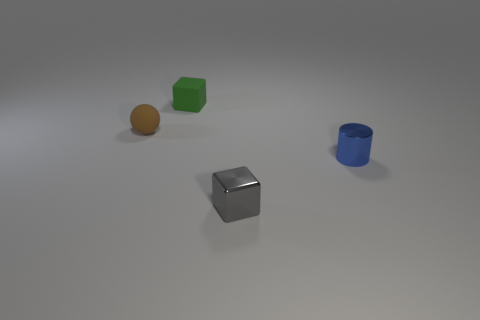What number of metallic things have the same size as the gray shiny block?
Offer a terse response. 1. What number of blue shiny cylinders are there?
Your response must be concise. 1. Is the material of the green block the same as the block in front of the green block?
Provide a short and direct response. No. How many gray objects are either metallic cylinders or small cubes?
Your response must be concise. 1. What size is the thing that is the same material as the small green block?
Your answer should be compact. Small. What number of green things are the same shape as the small brown rubber thing?
Your answer should be very brief. 0. Is the number of tiny gray metallic objects that are behind the gray cube greater than the number of brown rubber balls on the right side of the shiny cylinder?
Give a very brief answer. No. Is the color of the small cylinder the same as the rubber thing that is left of the small green rubber thing?
Make the answer very short. No. There is a brown sphere that is the same size as the blue thing; what material is it?
Provide a short and direct response. Rubber. What number of things are either large matte objects or tiny brown spheres that are left of the gray cube?
Your response must be concise. 1. 